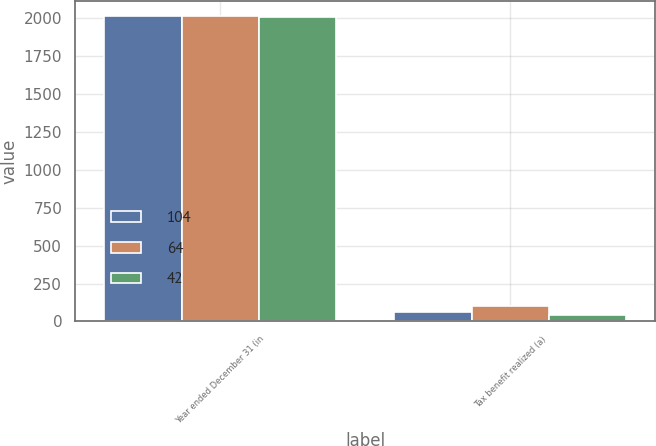<chart> <loc_0><loc_0><loc_500><loc_500><stacked_bar_chart><ecel><fcel>Year ended December 31 (in<fcel>Tax benefit realized (a)<nl><fcel>104<fcel>2015<fcel>64<nl><fcel>64<fcel>2014<fcel>104<nl><fcel>42<fcel>2013<fcel>42<nl></chart> 